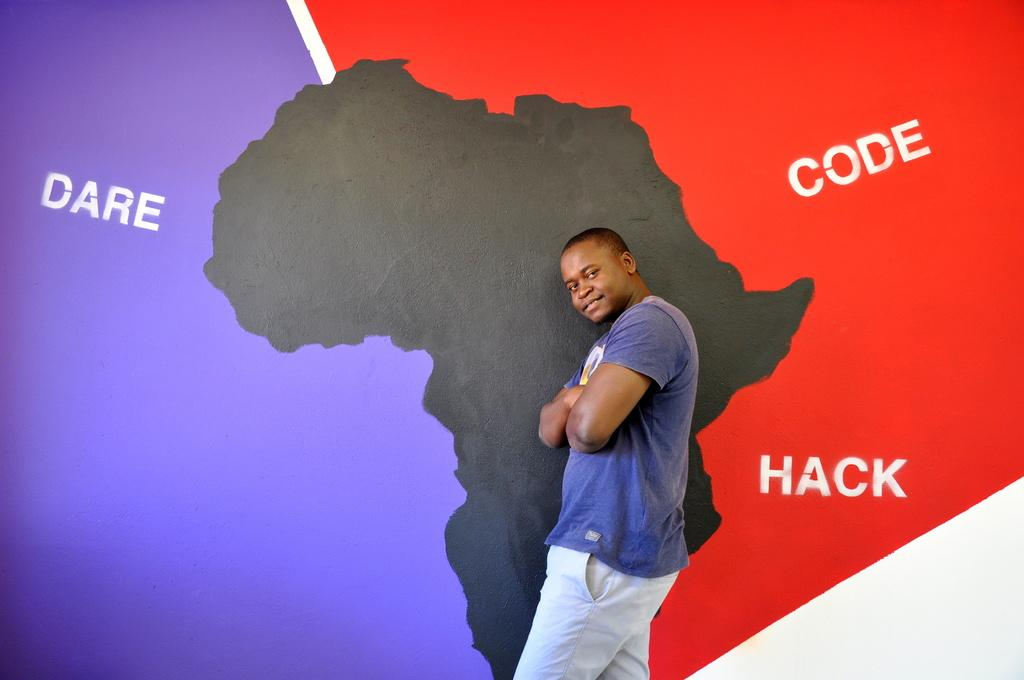<image>
Offer a succinct explanation of the picture presented. a map that has the word dare on the left 